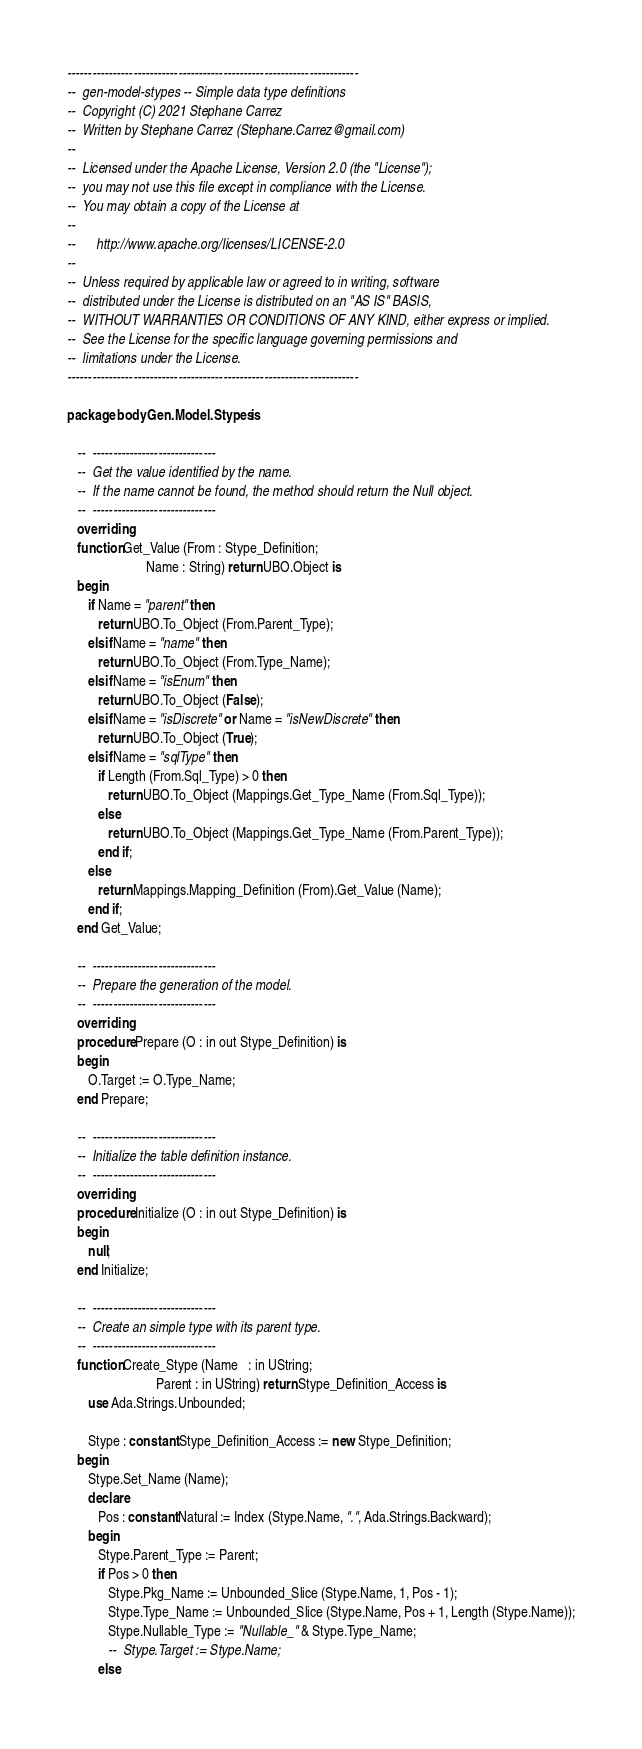Convert code to text. <code><loc_0><loc_0><loc_500><loc_500><_Ada_>-----------------------------------------------------------------------
--  gen-model-stypes -- Simple data type definitions
--  Copyright (C) 2021 Stephane Carrez
--  Written by Stephane Carrez (Stephane.Carrez@gmail.com)
--
--  Licensed under the Apache License, Version 2.0 (the "License");
--  you may not use this file except in compliance with the License.
--  You may obtain a copy of the License at
--
--      http://www.apache.org/licenses/LICENSE-2.0
--
--  Unless required by applicable law or agreed to in writing, software
--  distributed under the License is distributed on an "AS IS" BASIS,
--  WITHOUT WARRANTIES OR CONDITIONS OF ANY KIND, either express or implied.
--  See the License for the specific language governing permissions and
--  limitations under the License.
-----------------------------------------------------------------------

package body Gen.Model.Stypes is

   --  ------------------------------
   --  Get the value identified by the name.
   --  If the name cannot be found, the method should return the Null object.
   --  ------------------------------
   overriding
   function Get_Value (From : Stype_Definition;
                       Name : String) return UBO.Object is
   begin
      if Name = "parent" then
         return UBO.To_Object (From.Parent_Type);
      elsif Name = "name" then
         return UBO.To_Object (From.Type_Name);
      elsif Name = "isEnum" then
         return UBO.To_Object (False);
      elsif Name = "isDiscrete" or Name = "isNewDiscrete" then
         return UBO.To_Object (True);
      elsif Name = "sqlType" then
         if Length (From.Sql_Type) > 0 then
            return UBO.To_Object (Mappings.Get_Type_Name (From.Sql_Type));
         else
            return UBO.To_Object (Mappings.Get_Type_Name (From.Parent_Type));
         end if;
      else
         return Mappings.Mapping_Definition (From).Get_Value (Name);
      end if;
   end Get_Value;

   --  ------------------------------
   --  Prepare the generation of the model.
   --  ------------------------------
   overriding
   procedure Prepare (O : in out Stype_Definition) is
   begin
      O.Target := O.Type_Name;
   end Prepare;

   --  ------------------------------
   --  Initialize the table definition instance.
   --  ------------------------------
   overriding
   procedure Initialize (O : in out Stype_Definition) is
   begin
      null;
   end Initialize;

   --  ------------------------------
   --  Create an simple type with its parent type.
   --  ------------------------------
   function Create_Stype (Name   : in UString;
                          Parent : in UString) return Stype_Definition_Access is
      use Ada.Strings.Unbounded;

      Stype : constant Stype_Definition_Access := new Stype_Definition;
   begin
      Stype.Set_Name (Name);
      declare
         Pos : constant Natural := Index (Stype.Name, ".", Ada.Strings.Backward);
      begin
         Stype.Parent_Type := Parent;
         if Pos > 0 then
            Stype.Pkg_Name := Unbounded_Slice (Stype.Name, 1, Pos - 1);
            Stype.Type_Name := Unbounded_Slice (Stype.Name, Pos + 1, Length (Stype.Name));
            Stype.Nullable_Type := "Nullable_" & Stype.Type_Name;
            --  Stype.Target := Stype.Name;
         else</code> 